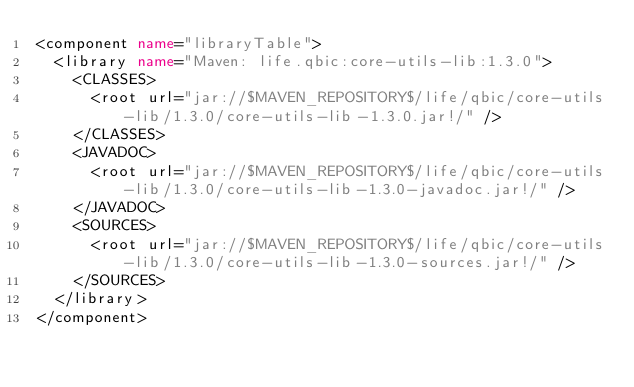Convert code to text. <code><loc_0><loc_0><loc_500><loc_500><_XML_><component name="libraryTable">
  <library name="Maven: life.qbic:core-utils-lib:1.3.0">
    <CLASSES>
      <root url="jar://$MAVEN_REPOSITORY$/life/qbic/core-utils-lib/1.3.0/core-utils-lib-1.3.0.jar!/" />
    </CLASSES>
    <JAVADOC>
      <root url="jar://$MAVEN_REPOSITORY$/life/qbic/core-utils-lib/1.3.0/core-utils-lib-1.3.0-javadoc.jar!/" />
    </JAVADOC>
    <SOURCES>
      <root url="jar://$MAVEN_REPOSITORY$/life/qbic/core-utils-lib/1.3.0/core-utils-lib-1.3.0-sources.jar!/" />
    </SOURCES>
  </library>
</component></code> 